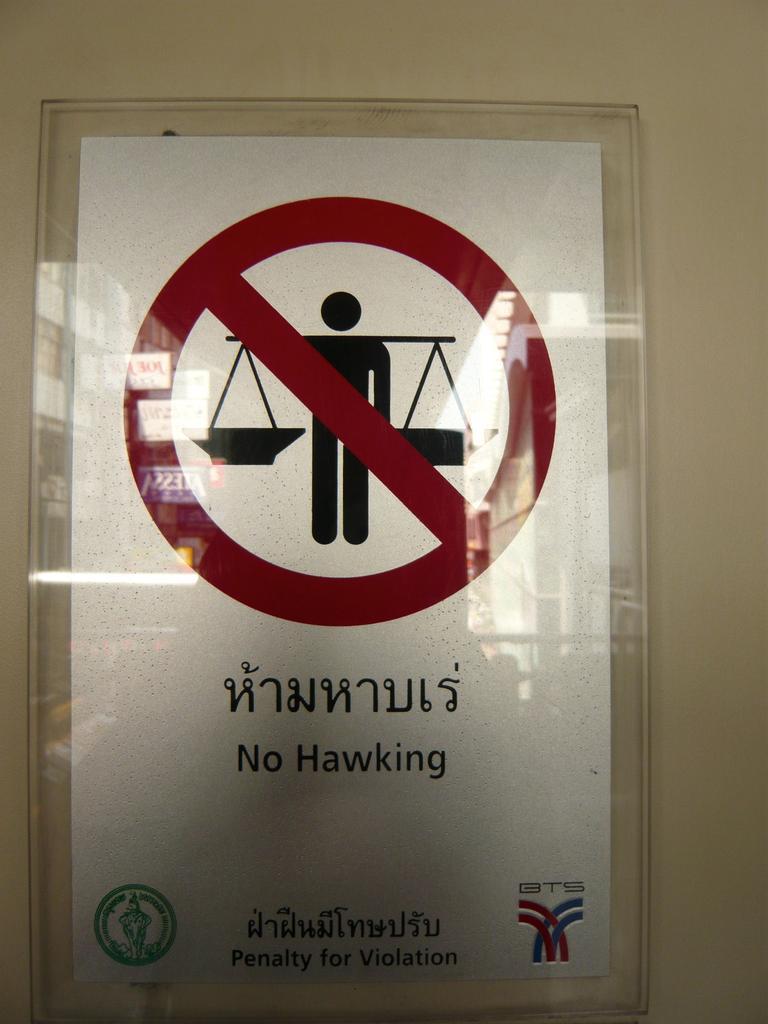Describe this image in one or two sentences. In this picture I can see a poster in the glass box and I can see text and I can see a caution sign at the top and couple of logos at the bottom of the picture, It looks like a sign board. 